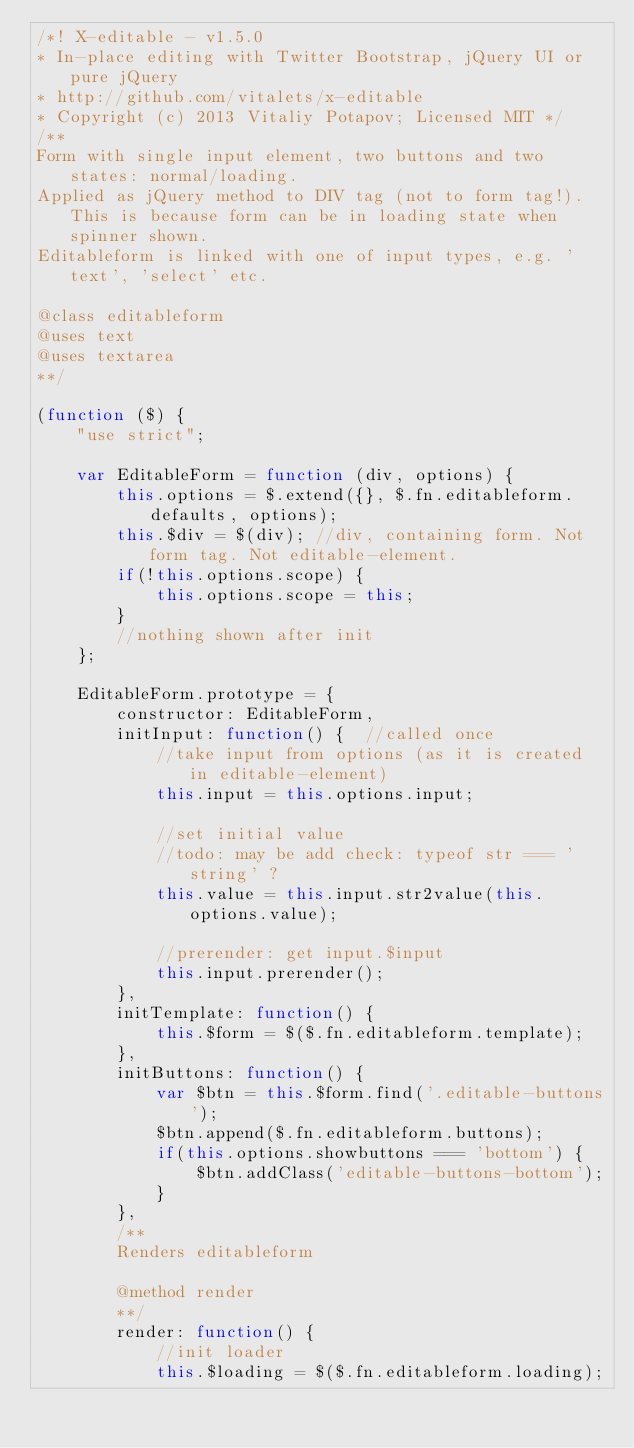<code> <loc_0><loc_0><loc_500><loc_500><_JavaScript_>/*! X-editable - v1.5.0 
* In-place editing with Twitter Bootstrap, jQuery UI or pure jQuery
* http://github.com/vitalets/x-editable
* Copyright (c) 2013 Vitaliy Potapov; Licensed MIT */
/**
Form with single input element, two buttons and two states: normal/loading.
Applied as jQuery method to DIV tag (not to form tag!). This is because form can be in loading state when spinner shown.
Editableform is linked with one of input types, e.g. 'text', 'select' etc.

@class editableform
@uses text
@uses textarea
**/

(function ($) {
    "use strict";
    
    var EditableForm = function (div, options) {
        this.options = $.extend({}, $.fn.editableform.defaults, options);
        this.$div = $(div); //div, containing form. Not form tag. Not editable-element.
        if(!this.options.scope) {
            this.options.scope = this;
        }
        //nothing shown after init
    };

    EditableForm.prototype = {
        constructor: EditableForm,
        initInput: function() {  //called once
            //take input from options (as it is created in editable-element)
            this.input = this.options.input;
            
            //set initial value
            //todo: may be add check: typeof str === 'string' ? 
            this.value = this.input.str2value(this.options.value); 
            
            //prerender: get input.$input
            this.input.prerender();
        },
        initTemplate: function() {
            this.$form = $($.fn.editableform.template); 
        },
        initButtons: function() {
            var $btn = this.$form.find('.editable-buttons');
            $btn.append($.fn.editableform.buttons);
            if(this.options.showbuttons === 'bottom') {
                $btn.addClass('editable-buttons-bottom');
            }
        },
        /**
        Renders editableform

        @method render
        **/        
        render: function() {
            //init loader
            this.$loading = $($.fn.editableform.loading);        </code> 